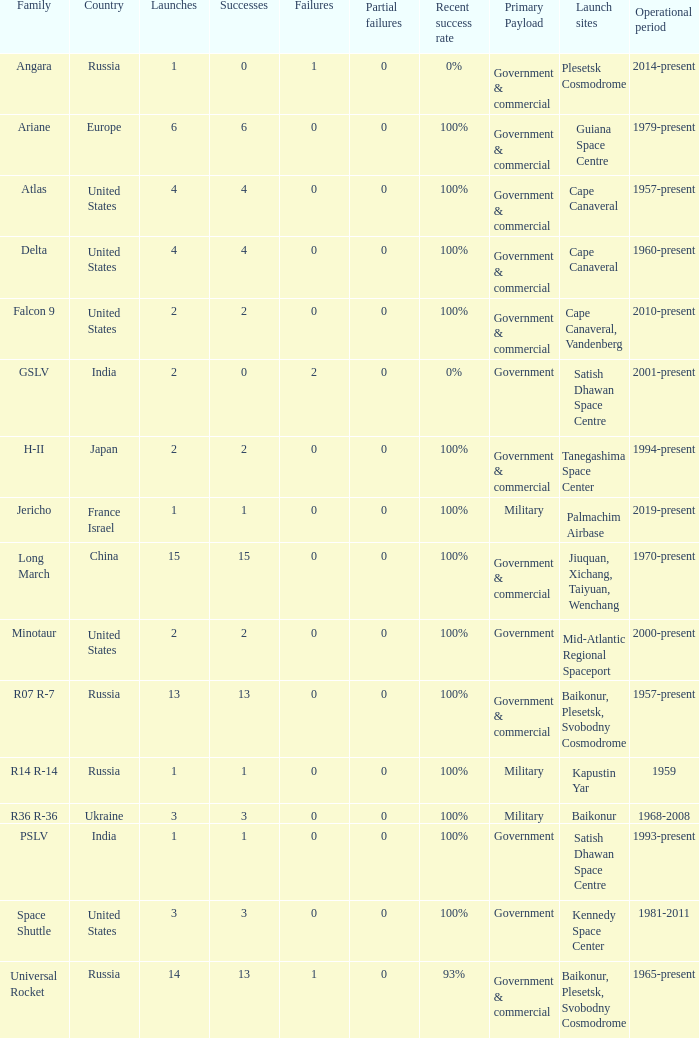What is the partial failure for the Country of russia, and a Failure larger than 0, and a Family of angara, and a Launch larger than 1? None. Give me the full table as a dictionary. {'header': ['Family', 'Country', 'Launches', 'Successes', 'Failures', 'Partial failures', 'Recent success rate', 'Primary Payload', 'Launch sites', 'Operational period'], 'rows': [['Angara', 'Russia', '1', '0', '1', '0', '0%', 'Government & commercial', 'Plesetsk Cosmodrome', '2014-present'], ['Ariane', 'Europe', '6', '6', '0', '0', '100%', 'Government & commercial', 'Guiana Space Centre', '1979-present'], ['Atlas', 'United States', '4', '4', '0', '0', '100%', 'Government & commercial', 'Cape Canaveral', '1957-present'], ['Delta', 'United States', '4', '4', '0', '0', '100%', 'Government & commercial', 'Cape Canaveral', '1960-present'], ['Falcon 9', 'United States', '2', '2', '0', '0', '100%', 'Government & commercial', 'Cape Canaveral, Vandenberg', '2010-present'], ['GSLV', 'India', '2', '0', '2', '0', '0%', 'Government', 'Satish Dhawan Space Centre', '2001-present'], ['H-II', 'Japan', '2', '2', '0', '0', '100%', 'Government & commercial', 'Tanegashima Space Center', '1994-present'], ['Jericho', 'France Israel', '1', '1', '0', '0', '100%', 'Military', 'Palmachim Airbase', '2019-present'], ['Long March', 'China', '15', '15', '0', '0', '100%', 'Government & commercial', 'Jiuquan, Xichang, Taiyuan, Wenchang', '1970-present'], ['Minotaur', 'United States', '2', '2', '0', '0', '100%', 'Government', 'Mid-Atlantic Regional Spaceport', '2000-present'], ['R07 R-7', 'Russia', '13', '13', '0', '0', '100%', 'Government & commercial', 'Baikonur, Plesetsk, Svobodny Cosmodrome', '1957-present'], ['R14 R-14', 'Russia', '1', '1', '0', '0', '100%', 'Military', 'Kapustin Yar', '1959'], ['R36 R-36', 'Ukraine', '3', '3', '0', '0', '100%', 'Military', 'Baikonur', '1968-2008'], ['PSLV', 'India', '1', '1', '0', '0', '100%', 'Government', 'Satish Dhawan Space Centre', '1993-present'], ['Space Shuttle', 'United States', '3', '3', '0', '0', '100%', 'Government', 'Kennedy Space Center', '1981-2011'], ['Universal Rocket', 'Russia', '14', '13', '1', '0', '93%', 'Government & commercial', 'Baikonur, Plesetsk, Svobodny Cosmodrome', '1965-present']]} 